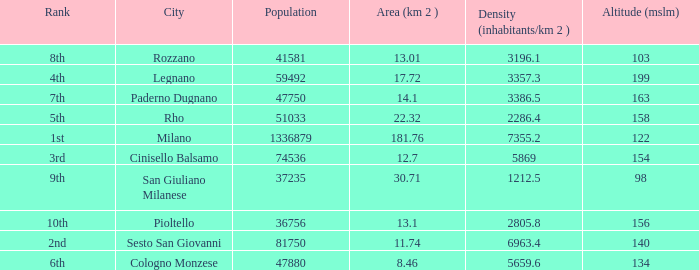Which Altitude (mslm) is the highest one that has a City of legnano, and a Population larger than 59492? None. 